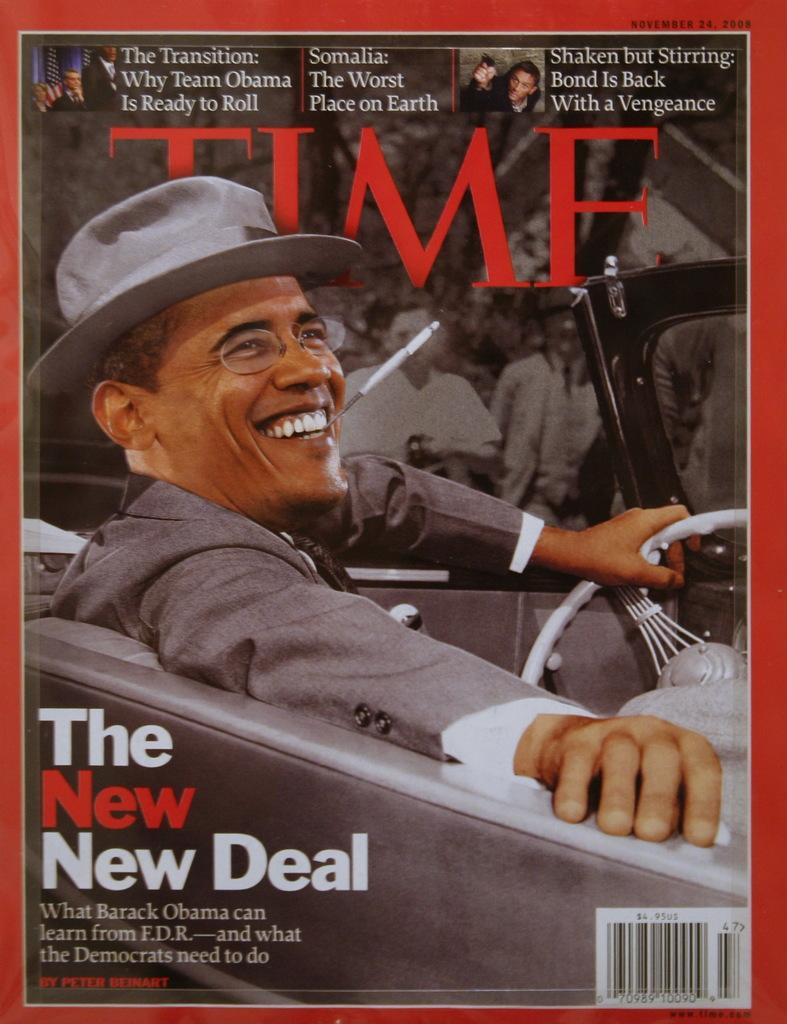<image>
Share a concise interpretation of the image provided. A cover of Time Magazine with Obama pictured and The New New Deal. 